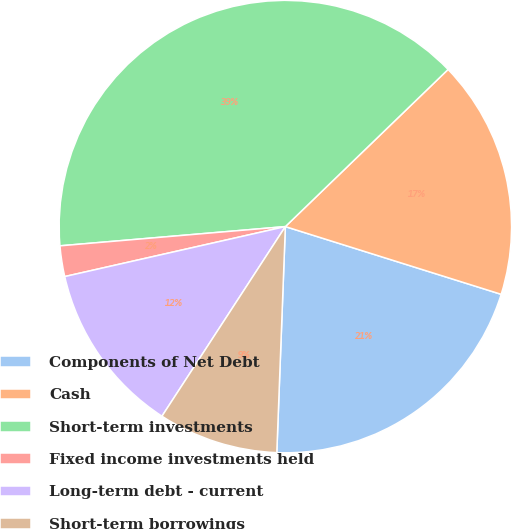<chart> <loc_0><loc_0><loc_500><loc_500><pie_chart><fcel>Components of Net Debt<fcel>Cash<fcel>Short-term investments<fcel>Fixed income investments held<fcel>Long-term debt - current<fcel>Short-term borrowings<nl><fcel>20.76%<fcel>17.06%<fcel>39.13%<fcel>2.19%<fcel>12.27%<fcel>8.58%<nl></chart> 